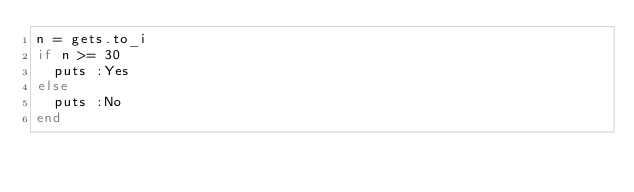<code> <loc_0><loc_0><loc_500><loc_500><_Ruby_>n = gets.to_i
if n >= 30
  puts :Yes
else
  puts :No
end</code> 